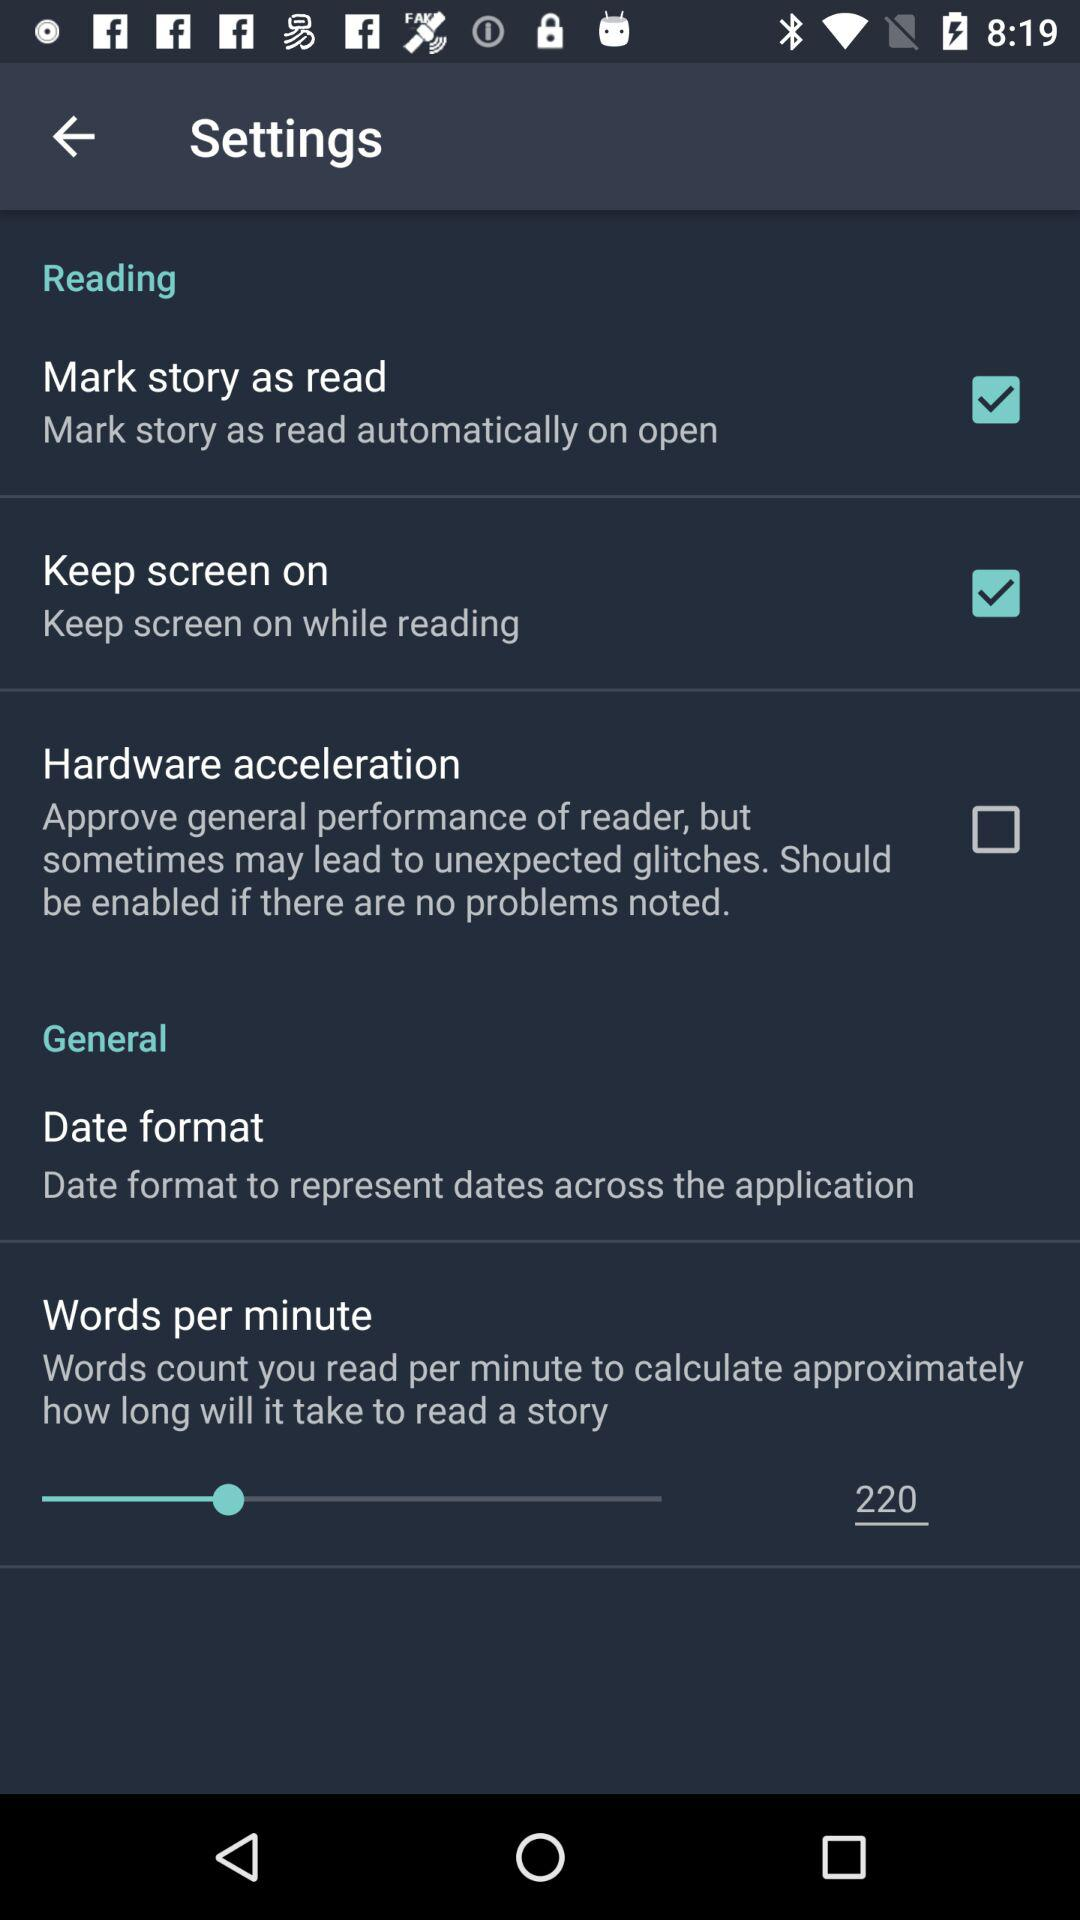What is the status of "Keep screen on"? The status is "on". 